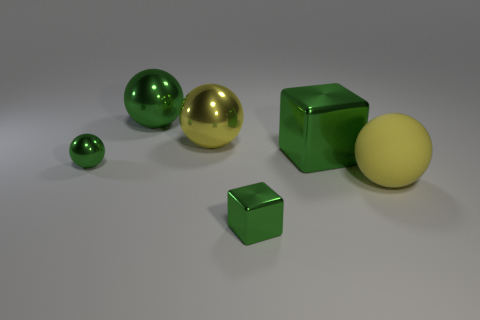Is the number of tiny shiny objects that are in front of the tiny sphere greater than the number of large metal cubes on the right side of the big metallic cube?
Make the answer very short. Yes. There is a yellow rubber thing; is its shape the same as the small metal object in front of the small sphere?
Offer a very short reply. No. What number of other things are there of the same shape as the big yellow rubber object?
Make the answer very short. 3. There is a shiny ball that is both in front of the big green metallic sphere and on the right side of the small ball; what is its color?
Your answer should be very brief. Yellow. The tiny cube is what color?
Your answer should be compact. Green. Do the small green cube and the big yellow ball behind the yellow matte object have the same material?
Offer a very short reply. Yes. There is a tiny green thing that is made of the same material as the small green sphere; what shape is it?
Your response must be concise. Cube. The shiny block that is the same size as the yellow matte ball is what color?
Provide a short and direct response. Green. There is a shiny sphere that is in front of the yellow shiny ball; does it have the same size as the large yellow rubber object?
Your response must be concise. No. Is the color of the small block the same as the rubber thing?
Provide a succinct answer. No. 